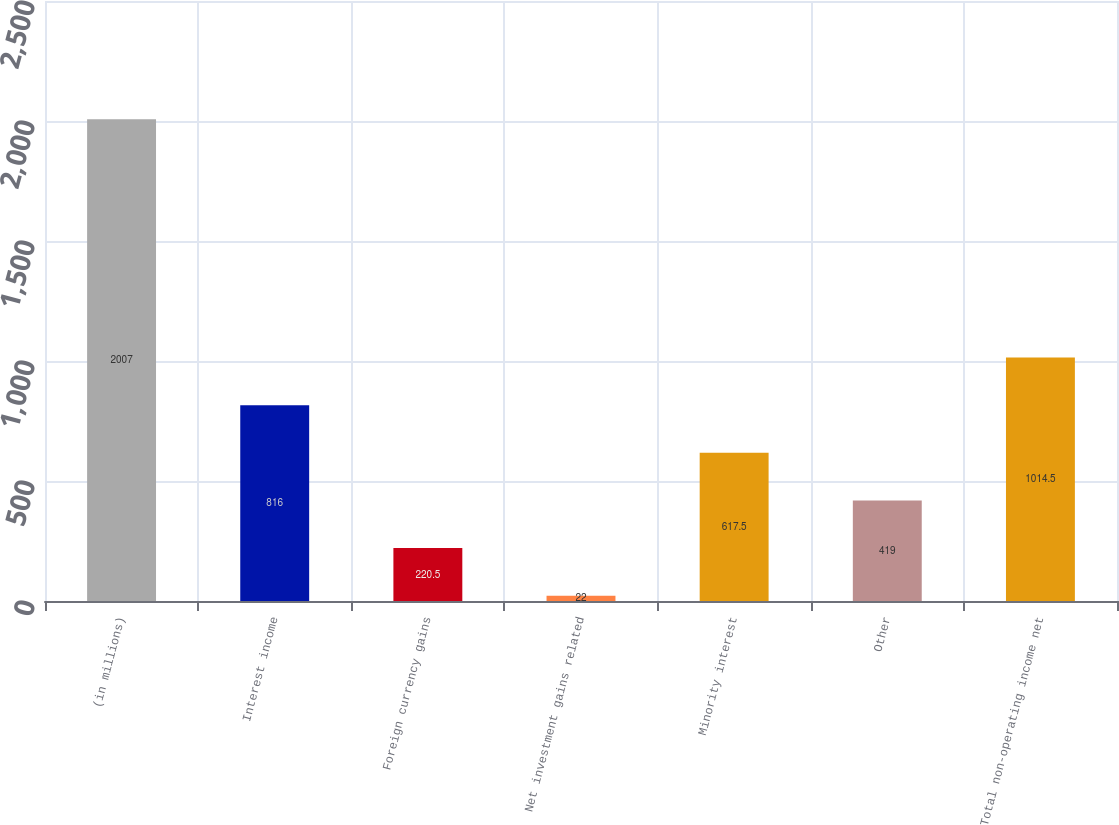<chart> <loc_0><loc_0><loc_500><loc_500><bar_chart><fcel>(in millions)<fcel>Interest income<fcel>Foreign currency gains<fcel>Net investment gains related<fcel>Minority interest<fcel>Other<fcel>Total non-operating income net<nl><fcel>2007<fcel>816<fcel>220.5<fcel>22<fcel>617.5<fcel>419<fcel>1014.5<nl></chart> 